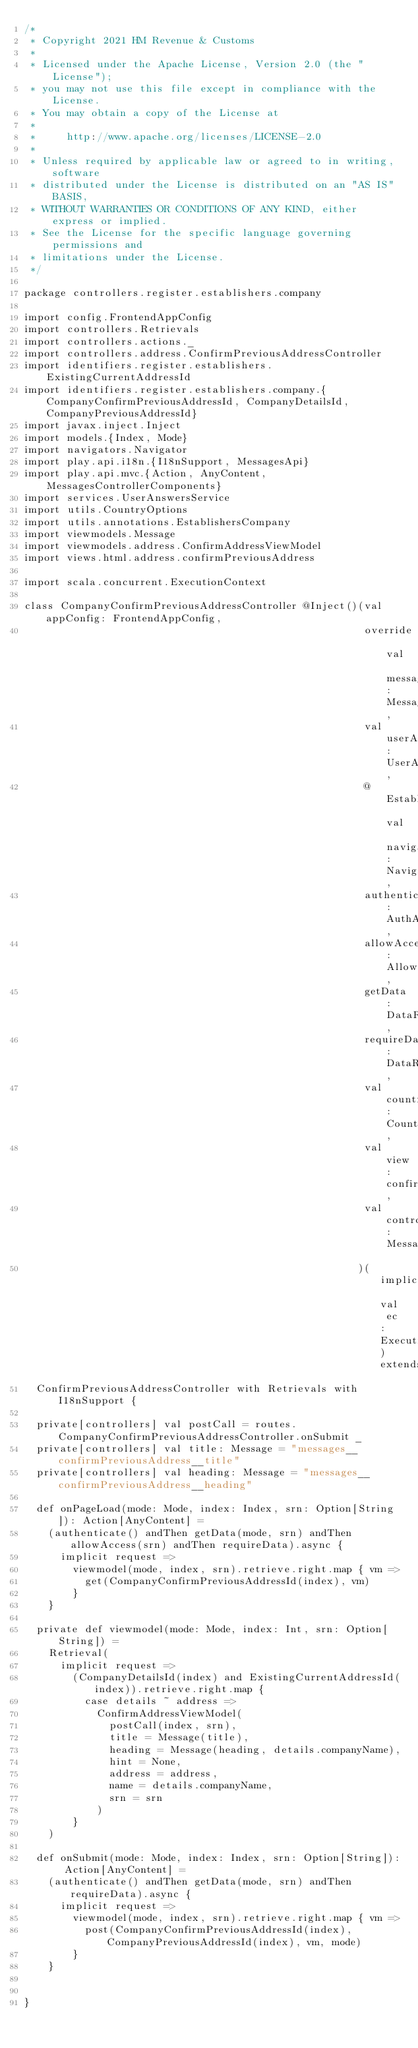Convert code to text. <code><loc_0><loc_0><loc_500><loc_500><_Scala_>/*
 * Copyright 2021 HM Revenue & Customs
 *
 * Licensed under the Apache License, Version 2.0 (the "License");
 * you may not use this file except in compliance with the License.
 * You may obtain a copy of the License at
 *
 *     http://www.apache.org/licenses/LICENSE-2.0
 *
 * Unless required by applicable law or agreed to in writing, software
 * distributed under the License is distributed on an "AS IS" BASIS,
 * WITHOUT WARRANTIES OR CONDITIONS OF ANY KIND, either express or implied.
 * See the License for the specific language governing permissions and
 * limitations under the License.
 */

package controllers.register.establishers.company

import config.FrontendAppConfig
import controllers.Retrievals
import controllers.actions._
import controllers.address.ConfirmPreviousAddressController
import identifiers.register.establishers.ExistingCurrentAddressId
import identifiers.register.establishers.company.{CompanyConfirmPreviousAddressId, CompanyDetailsId, CompanyPreviousAddressId}
import javax.inject.Inject
import models.{Index, Mode}
import navigators.Navigator
import play.api.i18n.{I18nSupport, MessagesApi}
import play.api.mvc.{Action, AnyContent, MessagesControllerComponents}
import services.UserAnswersService
import utils.CountryOptions
import utils.annotations.EstablishersCompany
import viewmodels.Message
import viewmodels.address.ConfirmAddressViewModel
import views.html.address.confirmPreviousAddress

import scala.concurrent.ExecutionContext

class CompanyConfirmPreviousAddressController @Inject()(val appConfig: FrontendAppConfig,
                                                        override val messagesApi: MessagesApi,
                                                        val userAnswersService: UserAnswersService,
                                                        @EstablishersCompany val navigator: Navigator,
                                                        authenticate: AuthAction,
                                                        allowAccess: AllowAccessActionProvider,
                                                        getData: DataRetrievalAction,
                                                        requireData: DataRequiredAction,
                                                        val countryOptions: CountryOptions,
                                                        val view: confirmPreviousAddress,
                                                        val controllerComponents: MessagesControllerComponents
                                                       )(implicit val ec: ExecutionContext) extends
  ConfirmPreviousAddressController with Retrievals with I18nSupport {

  private[controllers] val postCall = routes.CompanyConfirmPreviousAddressController.onSubmit _
  private[controllers] val title: Message = "messages__confirmPreviousAddress__title"
  private[controllers] val heading: Message = "messages__confirmPreviousAddress__heading"

  def onPageLoad(mode: Mode, index: Index, srn: Option[String]): Action[AnyContent] =
    (authenticate() andThen getData(mode, srn) andThen allowAccess(srn) andThen requireData).async {
      implicit request =>
        viewmodel(mode, index, srn).retrieve.right.map { vm =>
          get(CompanyConfirmPreviousAddressId(index), vm)
        }
    }

  private def viewmodel(mode: Mode, index: Int, srn: Option[String]) =
    Retrieval(
      implicit request =>
        (CompanyDetailsId(index) and ExistingCurrentAddressId(index)).retrieve.right.map {
          case details ~ address =>
            ConfirmAddressViewModel(
              postCall(index, srn),
              title = Message(title),
              heading = Message(heading, details.companyName),
              hint = None,
              address = address,
              name = details.companyName,
              srn = srn
            )
        }
    )

  def onSubmit(mode: Mode, index: Index, srn: Option[String]): Action[AnyContent] =
    (authenticate() andThen getData(mode, srn) andThen requireData).async {
      implicit request =>
        viewmodel(mode, index, srn).retrieve.right.map { vm =>
          post(CompanyConfirmPreviousAddressId(index), CompanyPreviousAddressId(index), vm, mode)
        }
    }


}
</code> 